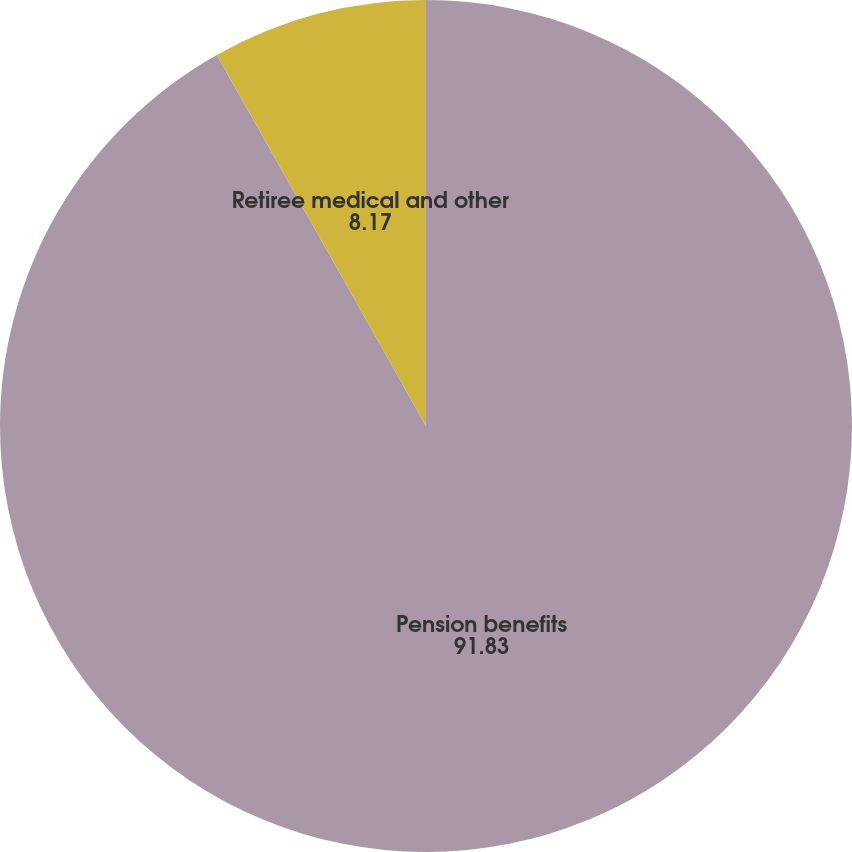<chart> <loc_0><loc_0><loc_500><loc_500><pie_chart><fcel>Pension benefits<fcel>Retiree medical and other<nl><fcel>91.83%<fcel>8.17%<nl></chart> 